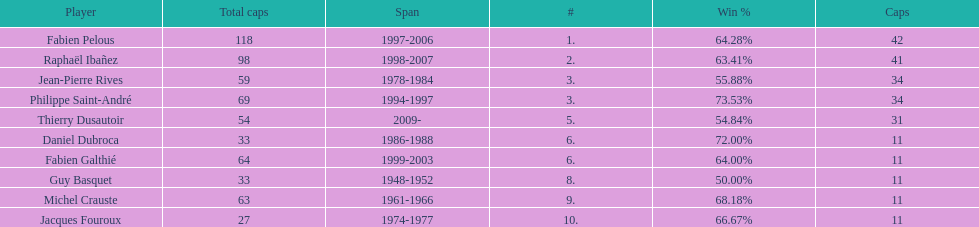Which captain served the least amount of time? Daniel Dubroca. 